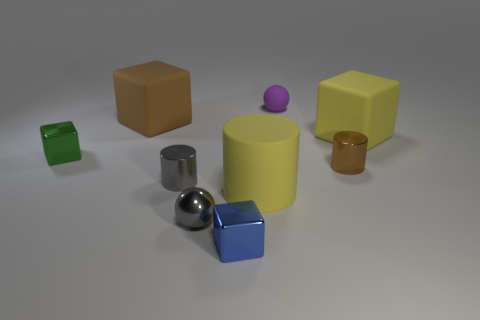Subtract all tiny cylinders. How many cylinders are left? 1 Subtract all brown cubes. How many cubes are left? 3 Add 1 tiny purple things. How many objects exist? 10 Subtract all cylinders. How many objects are left? 6 Subtract 3 cubes. How many cubes are left? 1 Subtract all green blocks. Subtract all gray cylinders. How many blocks are left? 3 Subtract all brown balls. How many gray cylinders are left? 1 Subtract all large matte blocks. Subtract all small objects. How many objects are left? 1 Add 6 blue things. How many blue things are left? 7 Add 6 big red cylinders. How many big red cylinders exist? 6 